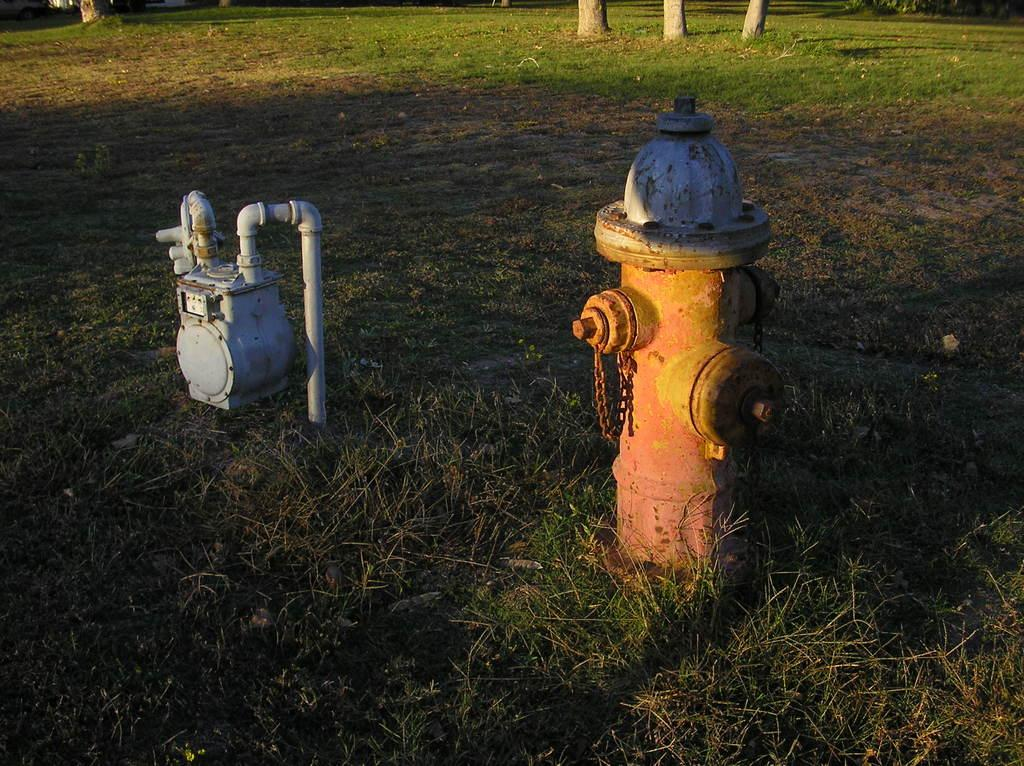What is the main object in the center of the image? There is a hydrant in the center of the image. What else can be seen on the ground in the image? There is a motor on the ground in the image. What can be seen in the background of the image? There are poles in the background of the image. How much salt is being used by the hydrant in the image? There is no salt present in the image, and the hydrant is not using any salt. What type of argument is taking place between the hydrant and the motor in the image? There is no argument taking place in the image, as the hydrant and motor are inanimate objects. 